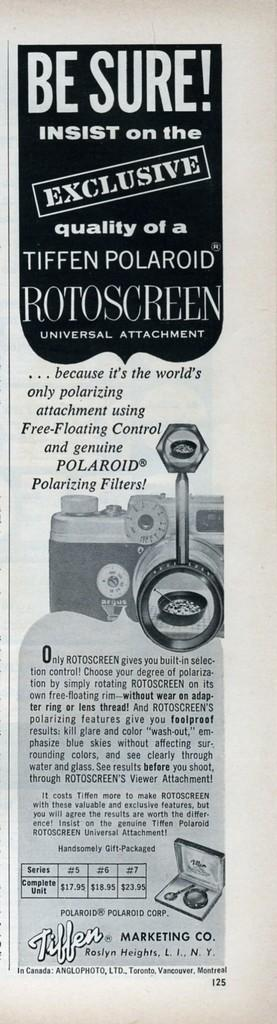What is the main object in the image? There is a paper in the image. What type of content is on the paper? The paper contains photos, words, and numbers. What type of flesh can be seen on the paper in the image? There is no flesh present on the paper in the image; it contains photos, words, and numbers. How many bananas are depicted on the paper in the image? There are no bananas depicted on the paper in the image. 